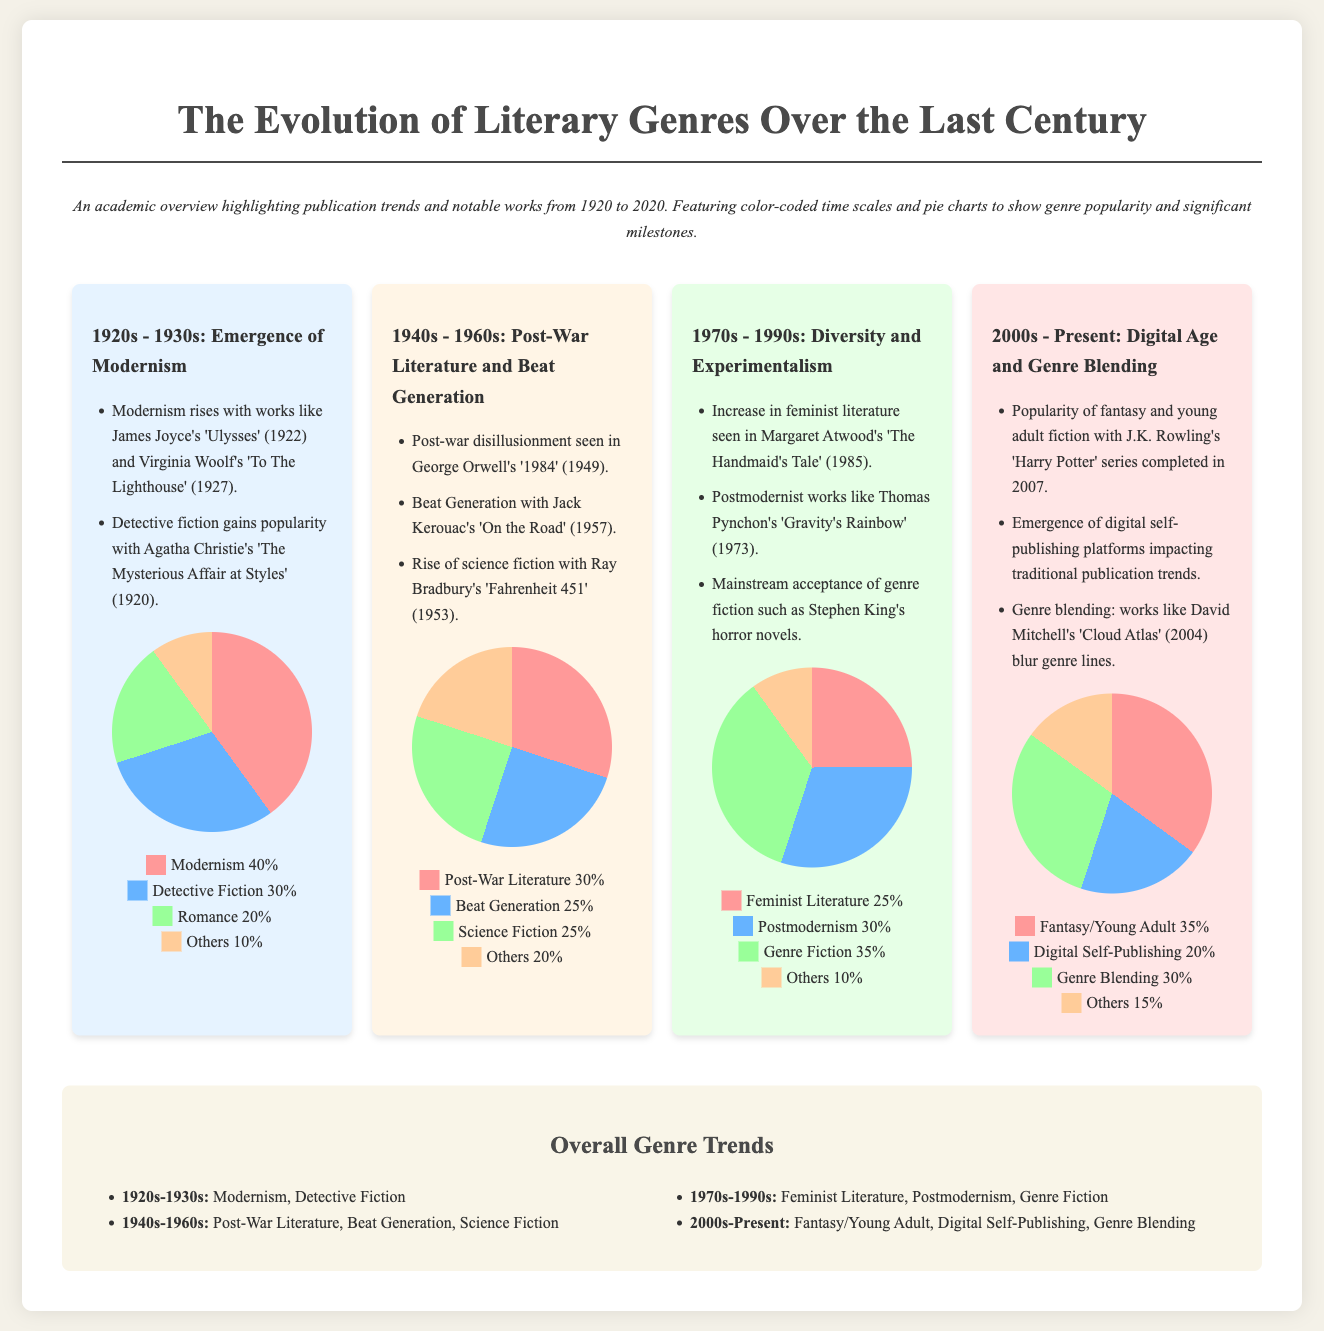what notable work was published in the 1920s? The notable work published in the 1920s is James Joyce's 'Ulysses' (1922).
Answer: 'Ulysses' which genre had the highest popularity in the 1970s to 1990s? The genre with the highest popularity in the 1970s to 1990s was Genre Fiction, accounting for 35%.
Answer: Genre Fiction what percentage of the genre pie chart corresponds to Post-War Literature in the 1940s to 1960s? Post-War Literature corresponds to 30% in the pie chart for the 1940s to 1960s.
Answer: 30% which era highlights the emerging theme of Digital Self-Publishing? The era highlighting the emerging theme of Digital Self-Publishing is the 2000s - Present.
Answer: 2000s - Present name one major characteristic of the 1980s literary scene according to the document. One major characteristic of the 1980s literary scene is the increase in feminist literature.
Answer: increase in feminist literature what was the legend color representing Science Fiction in the 1940s to 1960s era? The legend color representing Science Fiction is light blue (#66b3ff).
Answer: light blue how many total genres are represented in the 2000s - Present pie chart? There are four total genres represented in the 2000s - Present pie chart: Fantasy/Young Adult, Digital Self-Publishing, Genre Blending, and Others.
Answer: four which literary genre spiked in the decade following the completion of the Harry Potter series? The literary genre that spiked is Fantasy/Young Adult.
Answer: Fantasy/Young Adult which author is associated with the Beat Generation in the 1940s to 1960s timeframe? The author associated with the Beat Generation is Jack Kerouac.
Answer: Jack Kerouac 